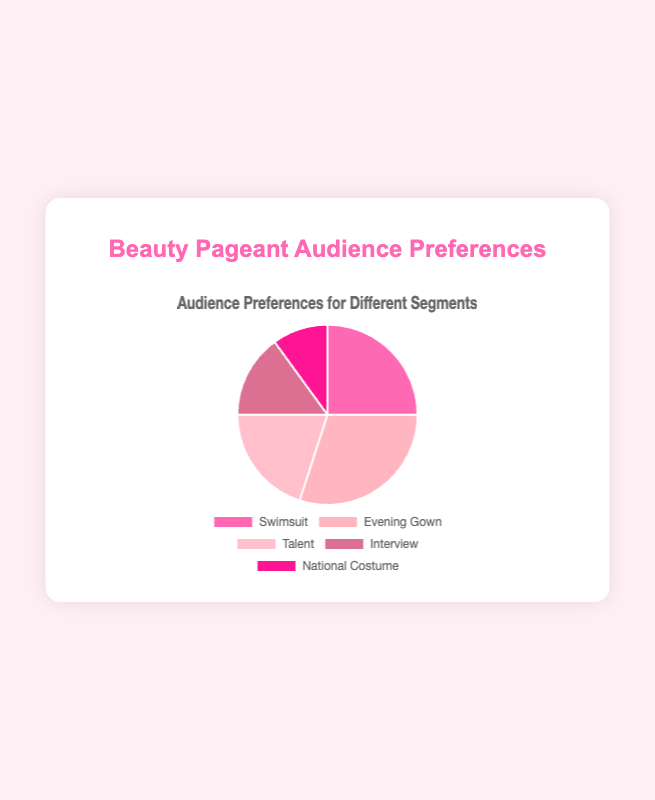Which segment has the highest preference among the audience? The segment with the highest preference is the one with the largest percentage in the pie chart. According to the data, the Evening Gown segment has the highest preference at 30%.
Answer: Evening Gown Which two segments have a combined preference that is closest to 50%? Adding the preferences for the two segments to find the ones closest to 50%. Swimsuit (25%) + Talent (20%) equals 45%, which is the closest to 50%.
Answer: Swimsuit and Talent How much greater is the preference for the Evening Gown compared to the National Costume segment? Subtract the preference for National Costume (10%) from Evening Gown (30%). 30% - 10% = 20%.
Answer: 20% What is the combined preference percentage for the Talent and Interview segments? Adding the percentages for the Talent (20%) and Interview (15%) segments. 20% + 15% = 35%.
Answer: 35% Which segment ranks third in audience preferences? By sorting the segments by percentage, Swimsuit (25%) ranks third after Evening Gown (30%) and Talent (20%).
Answer: Swimsuit What percentage of the audience prefers either Swimsuit or Evening Gown segments? Adding the percentages for the Swimsuit (25%) and Evening Gown (30%) segments. 25% + 30% = 55%.
Answer: 55% Is the preference for the Interview segment less than half of the preference for the Swimsuit segment? Comparing the preference for Interview (15%) to half of Swimsuit (25% / 2 = 12.5%). Since 15% is not less than 12.5%, the statement is false.
Answer: No What is the difference between the highest and lowest audience preferences? Subtracting the lowest segment preference, National Costume (10%), from the highest segment preference, Evening Gown (30%). 30% - 10% = 20%.
Answer: 20% If National Costume's preference was doubled, would it surpass any other segment's preference? Doubling National Costume's preference: 10% * 2 = 20%. The new preference would equal Talent (20%) but still be lower than Swimsuit (25%), Evening Gown (30%), as well as tying with Talent.
Answer: No Which segments have less than 20% audience preference? Identifying segments with preferences below 20%. Interview (15%) and National Costume (10%) both have less than 20% preference.
Answer: Interview and National Costume 